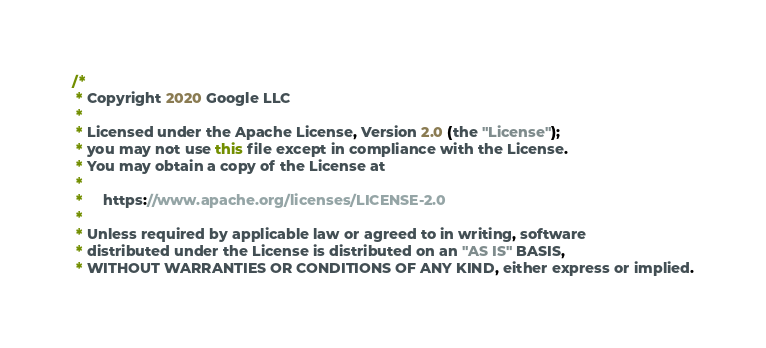Convert code to text. <code><loc_0><loc_0><loc_500><loc_500><_Java_>/*
 * Copyright 2020 Google LLC
 *
 * Licensed under the Apache License, Version 2.0 (the "License");
 * you may not use this file except in compliance with the License.
 * You may obtain a copy of the License at
 *
 *     https://www.apache.org/licenses/LICENSE-2.0
 *
 * Unless required by applicable law or agreed to in writing, software
 * distributed under the License is distributed on an "AS IS" BASIS,
 * WITHOUT WARRANTIES OR CONDITIONS OF ANY KIND, either express or implied.</code> 